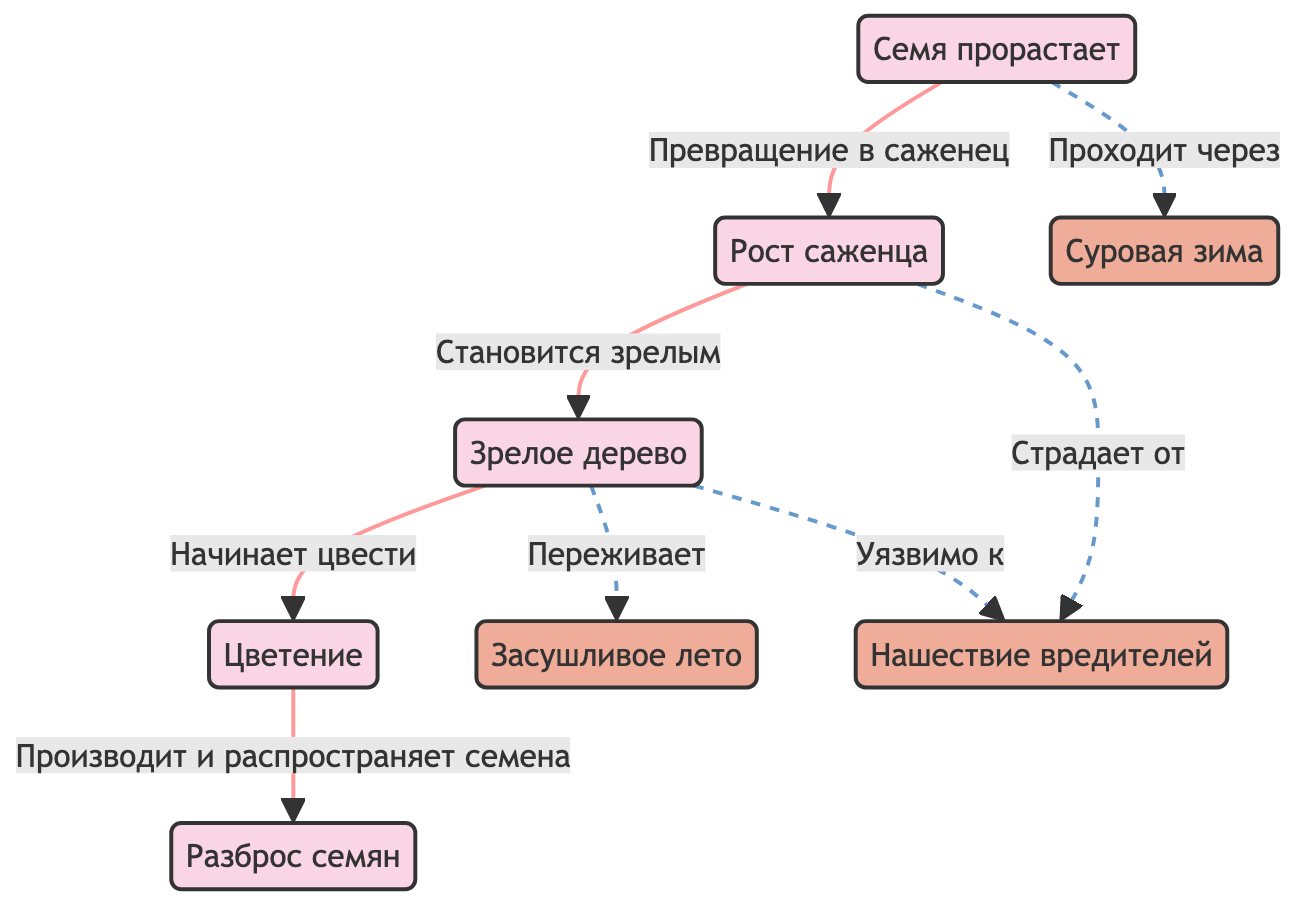What is the first stage in the life cycle? The diagram indicates that the first stage is "Семя прорастает", which translates to "Seed germination". It is the starting point of the flowchart, showing the initial step in the life cycle of a birch tree.
Answer: Семя прорастает How many main stages are there in the life cycle? By counting the nodes in the flowchart that represent the life stages of the birch tree, we find five distinct stages: seed germination, sapling growth, mature tree, flowering, and seed dispersal.
Answer: 5 What environmental condition affects the sapling stage? The diagram shows that "Страдает от" (suffers from) pests infestation connects to the "Рост саженца" (sapling growth) stage. This indicates that pests infestation impacts the health and growth of saplings.
Answer: Нашествие вредителей Which stage follows after flowering? The diagram indicates that after the "Цветение" (flowering) stage, the next step is "Разброс семян" (seed dispersal), conveying the process of seeds being produced and spread after the flowering stage.
Answer: Разброс семян What external factor does a mature tree survive during? The diagram indicates that a mature tree "Переживает" (survives) during "Засушливое лето" (dry summer), illustrating that this condition has an effect on mature trees, but they can endure it.
Answer: Засушливое лето What stage comes after sapling growth? Upon reviewing the diagram, it indicates that after "Рост саженца" (sapling growth), the next crucial stage is "Зрелое дерево" (mature tree), showing the progression from sapling to maturity.
Answer: Зрелое дерево How does harsh winter relate to seed germination? The relationship shown in the diagram indicates that "Семя прорастает" (seed germination) goes through "Суровая зима" (harsh winter), meaning this environmental condition is an obstacle faced during the germination stage.
Answer: Проходит через Which pests affect both sapling and mature tree stages? The diagram identifies that "Нашествие вредителей" (pests infestation) connects to both "Рост саженца" (sapling growth) and "Зрелое дерево" (mature tree), implying that pests can be detrimental at both of these life stages.
Answer: Нашествие вредителей What is the last stage in the life cycle? The final node in the diagram is "Разброс семян" (seed dispersal), which signifies the end of the life cycle, as it represents the culmination of the reproductive process of the birch tree after flowering.
Answer: Разброс семян 